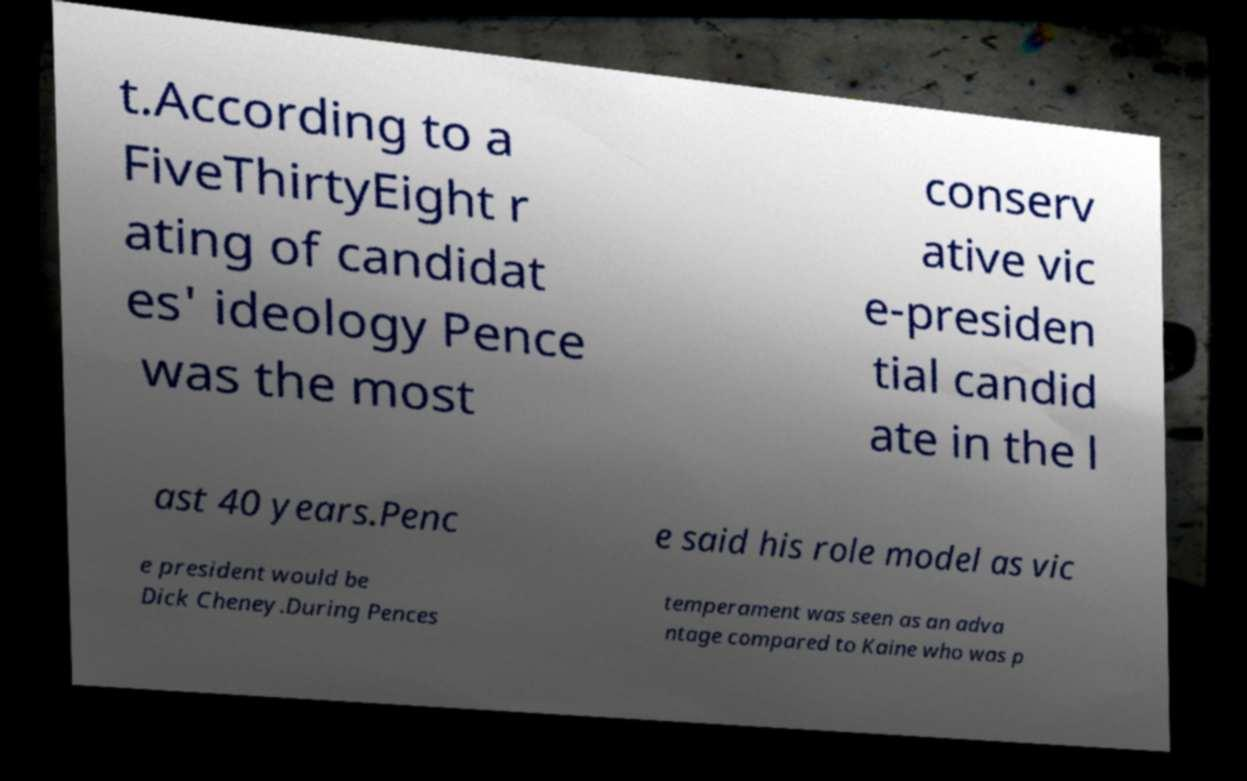Please identify and transcribe the text found in this image. t.According to a FiveThirtyEight r ating of candidat es' ideology Pence was the most conserv ative vic e-presiden tial candid ate in the l ast 40 years.Penc e said his role model as vic e president would be Dick Cheney.During Pences temperament was seen as an adva ntage compared to Kaine who was p 